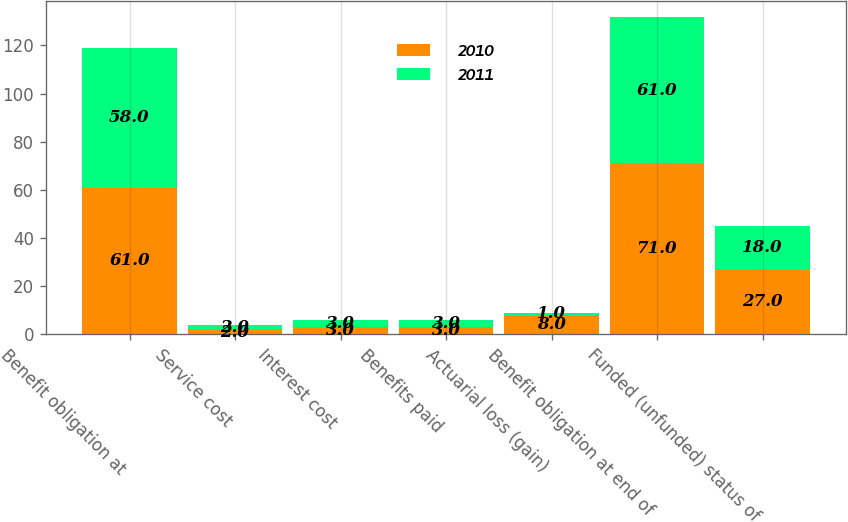Convert chart. <chart><loc_0><loc_0><loc_500><loc_500><stacked_bar_chart><ecel><fcel>Benefit obligation at<fcel>Service cost<fcel>Interest cost<fcel>Benefits paid<fcel>Actuarial loss (gain)<fcel>Benefit obligation at end of<fcel>Funded (unfunded) status of<nl><fcel>2010<fcel>61<fcel>2<fcel>3<fcel>3<fcel>8<fcel>71<fcel>27<nl><fcel>2011<fcel>58<fcel>2<fcel>3<fcel>3<fcel>1<fcel>61<fcel>18<nl></chart> 